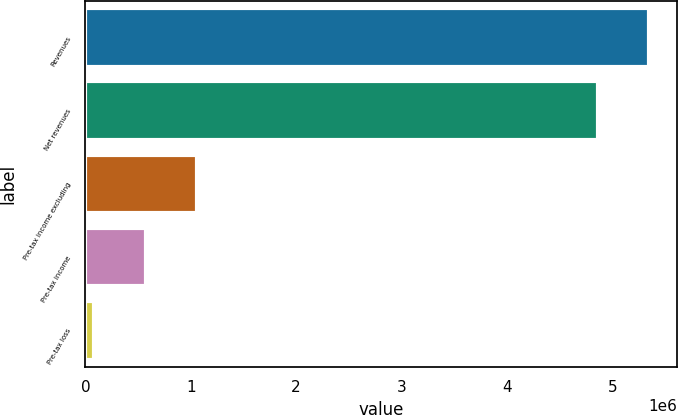Convert chart to OTSL. <chart><loc_0><loc_0><loc_500><loc_500><bar_chart><fcel>Revenues<fcel>Net revenues<fcel>Pre-tax income excluding<fcel>Pre-tax income<fcel>Pre-tax loss<nl><fcel>5.34952e+06<fcel>4.86137e+06<fcel>1.06023e+06<fcel>572072<fcel>83918<nl></chart> 